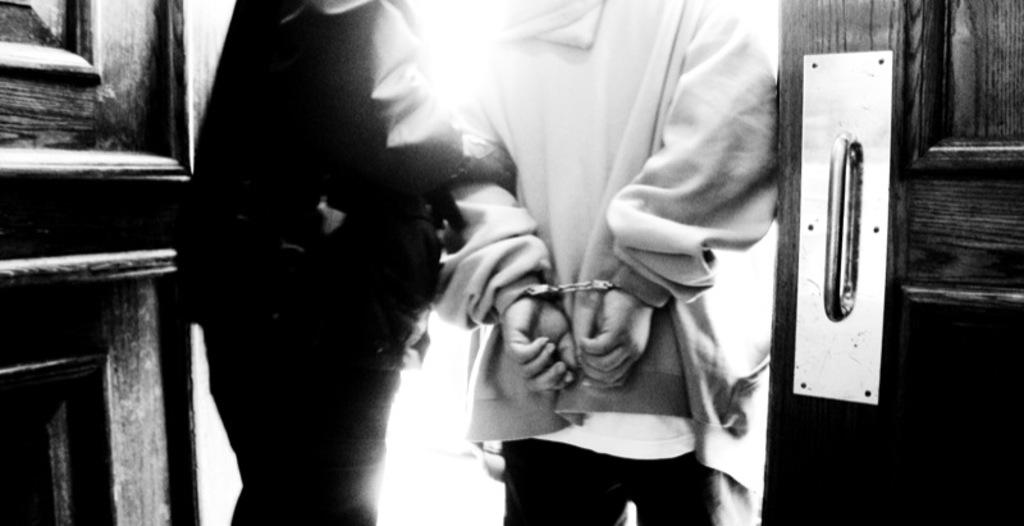What is the color scheme of the image? The image is black and white. Can you describe the people in the image? There are people in the image, and one person is wearing handcuffs. What can be seen in the background of the image? There are doors in the background of the image. What type of shirt is the daughter wearing in the image? There is no daughter present in the image, and therefore no shirt to describe. 